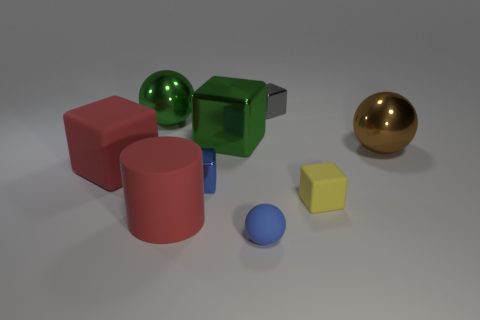Do the tiny sphere and the shiny thing on the left side of the red cylinder have the same color?
Give a very brief answer. No. Are there an equal number of tiny yellow rubber things on the left side of the red cylinder and small blue spheres behind the brown metal ball?
Your answer should be very brief. Yes. How many other things are there of the same size as the yellow rubber block?
Make the answer very short. 3. What size is the red rubber block?
Make the answer very short. Large. Does the big brown object have the same material as the tiny cube on the left side of the tiny gray shiny thing?
Give a very brief answer. Yes. Are there any tiny brown things of the same shape as the small yellow rubber thing?
Ensure brevity in your answer.  No. There is a blue block that is the same size as the rubber sphere; what is its material?
Offer a terse response. Metal. There is a metal block that is in front of the brown metal object; what is its size?
Provide a short and direct response. Small. There is a red matte cube that is behind the yellow rubber object; is it the same size as the metallic thing that is to the right of the small gray cube?
Offer a very short reply. Yes. What number of big red cylinders are made of the same material as the blue sphere?
Your response must be concise. 1. 